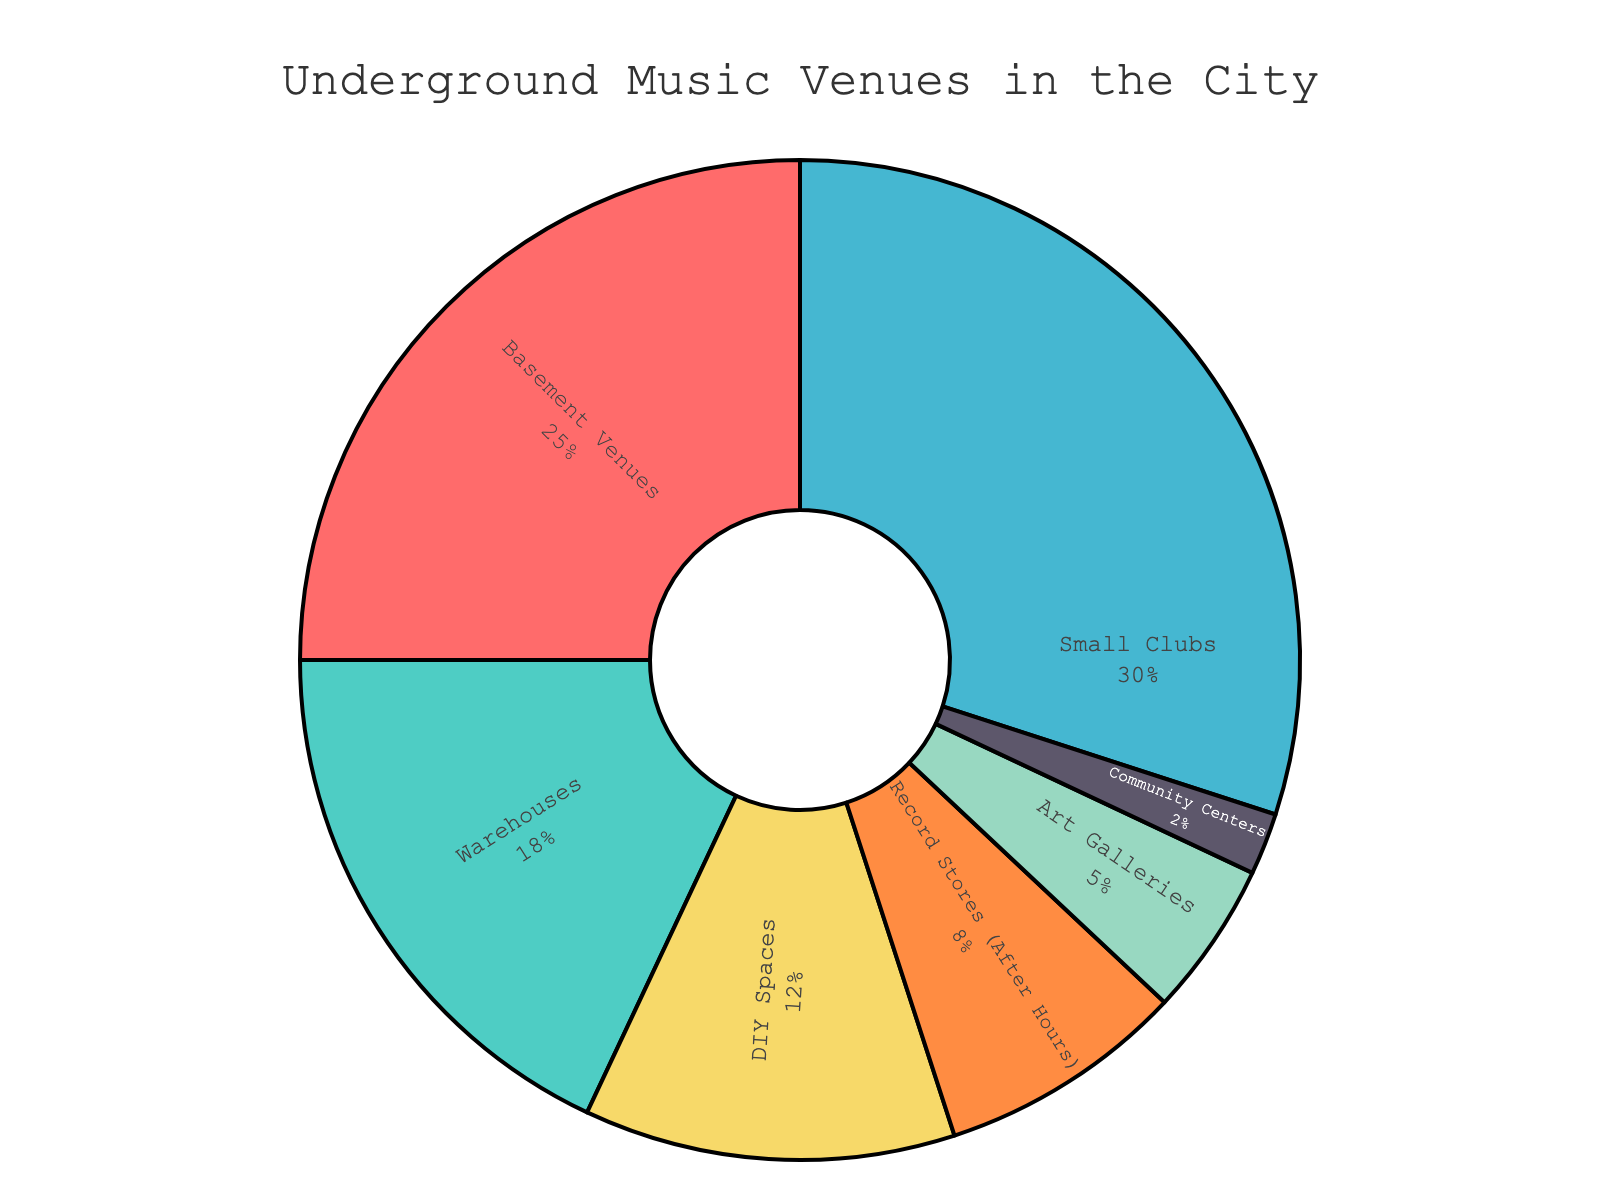What's the proportion of Basement Venues compared to Small Clubs? Basement Venues hold 25% of the total, while Small Clubs hold 30%. To compare, we note that Small Clubs have a 5% higher share.
Answer: Small Clubs have 5% more What's the combined percentage of Community Centers and Art Galleries? Community Centers hold 2% and Art Galleries hold 5%. Adding these percentages together, 2% + 5% = 7%.
Answer: 7% Which type of venue holds the second-highest percentage? Small Clubs have the highest percentage at 30%, and Basement Venues have the second-highest at 25%.
Answer: Basement Venues What is the difference in percentage between DIY Spaces and Record Stores (After Hours)? DIY Spaces account for 12%, and Record Stores (After Hours) account for 8%. The difference is 12% - 8% = 4%.
Answer: 4% How many types of venues hold a percentage less than 10%? DIY Spaces have 12%, Record Stores (After Hours) have 8%, Art Galleries have 5%, and Community Centers have 2%. Only Record Stores (After Hours), Art Galleries, and Community Centers are below 10%.
Answer: 3 What venue type occupies the largest portion, and what is its percentage? Small Clubs occupy the largest portion with a percentage of 30%.
Answer: Small Clubs, 30% Which venue types together constitute exactly 30% of the total? Community Centers (2%), Art Galleries (5%), and Record Stores (8%) sum up to 15%, which isn't 30%. DIY Spaces (12%) and Warehouses (18%) sum up to 30%.
Answer: DIY Spaces and Warehouses What is the total percentage for all venue types categorized as 'Spaces', such as DIY Spaces and Community Centers? DIY Spaces have 12% and Community Centers have 2%. Their total is 12% + 2% = 14%.
Answer: 14% What is the visual characteristic that all venue types share in this pie chart regarding color? Each venue type is represented by a distinct color in the pie chart. The colors are varied and visually distinct.
Answer: Distinct Colors 